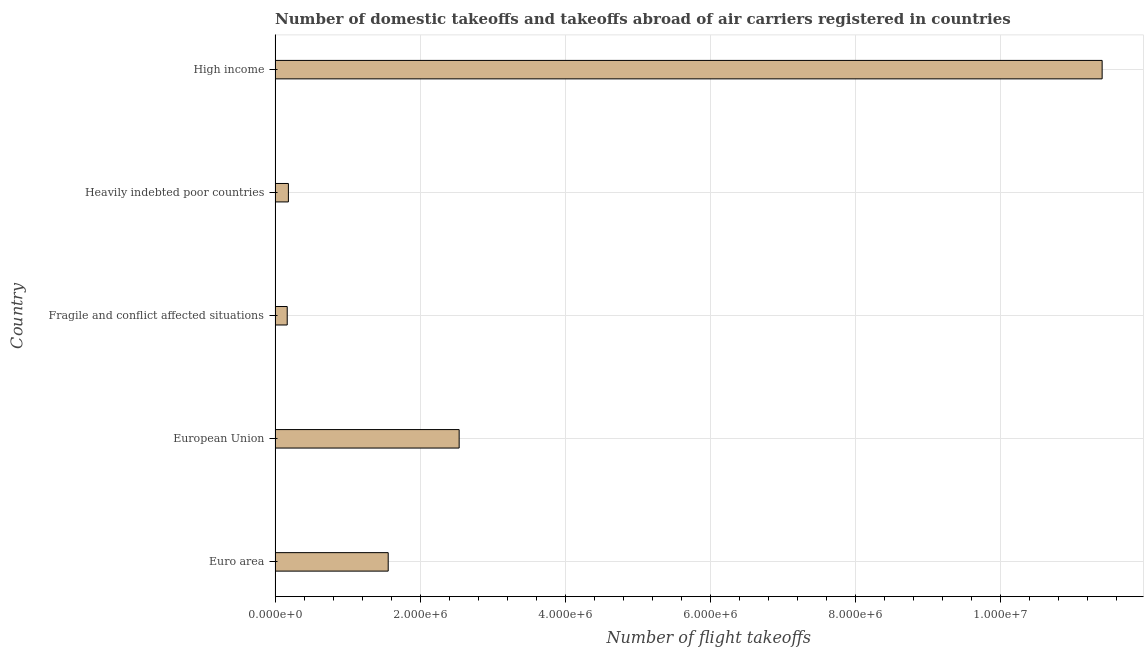Does the graph contain any zero values?
Offer a terse response. No. Does the graph contain grids?
Give a very brief answer. Yes. What is the title of the graph?
Give a very brief answer. Number of domestic takeoffs and takeoffs abroad of air carriers registered in countries. What is the label or title of the X-axis?
Keep it short and to the point. Number of flight takeoffs. What is the number of flight takeoffs in Fragile and conflict affected situations?
Provide a short and direct response. 1.67e+05. Across all countries, what is the maximum number of flight takeoffs?
Your response must be concise. 1.14e+07. Across all countries, what is the minimum number of flight takeoffs?
Offer a terse response. 1.67e+05. In which country was the number of flight takeoffs maximum?
Make the answer very short. High income. In which country was the number of flight takeoffs minimum?
Give a very brief answer. Fragile and conflict affected situations. What is the sum of the number of flight takeoffs?
Provide a short and direct response. 1.58e+07. What is the difference between the number of flight takeoffs in European Union and High income?
Your answer should be very brief. -8.86e+06. What is the average number of flight takeoffs per country?
Offer a very short reply. 3.17e+06. What is the median number of flight takeoffs?
Keep it short and to the point. 1.56e+06. In how many countries, is the number of flight takeoffs greater than 2800000 ?
Give a very brief answer. 1. What is the ratio of the number of flight takeoffs in Heavily indebted poor countries to that in High income?
Your response must be concise. 0.02. What is the difference between the highest and the second highest number of flight takeoffs?
Your answer should be very brief. 8.86e+06. Is the sum of the number of flight takeoffs in Euro area and Fragile and conflict affected situations greater than the maximum number of flight takeoffs across all countries?
Keep it short and to the point. No. What is the difference between the highest and the lowest number of flight takeoffs?
Keep it short and to the point. 1.12e+07. How many bars are there?
Offer a very short reply. 5. Are all the bars in the graph horizontal?
Give a very brief answer. Yes. How many countries are there in the graph?
Provide a succinct answer. 5. What is the difference between two consecutive major ticks on the X-axis?
Your answer should be compact. 2.00e+06. What is the Number of flight takeoffs of Euro area?
Provide a short and direct response. 1.56e+06. What is the Number of flight takeoffs in European Union?
Provide a succinct answer. 2.54e+06. What is the Number of flight takeoffs of Fragile and conflict affected situations?
Offer a very short reply. 1.67e+05. What is the Number of flight takeoffs of Heavily indebted poor countries?
Make the answer very short. 1.83e+05. What is the Number of flight takeoffs of High income?
Your response must be concise. 1.14e+07. What is the difference between the Number of flight takeoffs in Euro area and European Union?
Offer a very short reply. -9.78e+05. What is the difference between the Number of flight takeoffs in Euro area and Fragile and conflict affected situations?
Your answer should be very brief. 1.39e+06. What is the difference between the Number of flight takeoffs in Euro area and Heavily indebted poor countries?
Offer a very short reply. 1.38e+06. What is the difference between the Number of flight takeoffs in Euro area and High income?
Your response must be concise. -9.84e+06. What is the difference between the Number of flight takeoffs in European Union and Fragile and conflict affected situations?
Offer a terse response. 2.37e+06. What is the difference between the Number of flight takeoffs in European Union and Heavily indebted poor countries?
Your answer should be very brief. 2.35e+06. What is the difference between the Number of flight takeoffs in European Union and High income?
Your response must be concise. -8.86e+06. What is the difference between the Number of flight takeoffs in Fragile and conflict affected situations and Heavily indebted poor countries?
Provide a short and direct response. -1.60e+04. What is the difference between the Number of flight takeoffs in Fragile and conflict affected situations and High income?
Ensure brevity in your answer.  -1.12e+07. What is the difference between the Number of flight takeoffs in Heavily indebted poor countries and High income?
Provide a succinct answer. -1.12e+07. What is the ratio of the Number of flight takeoffs in Euro area to that in European Union?
Your answer should be very brief. 0.61. What is the ratio of the Number of flight takeoffs in Euro area to that in Fragile and conflict affected situations?
Keep it short and to the point. 9.32. What is the ratio of the Number of flight takeoffs in Euro area to that in Heavily indebted poor countries?
Offer a terse response. 8.5. What is the ratio of the Number of flight takeoffs in Euro area to that in High income?
Your response must be concise. 0.14. What is the ratio of the Number of flight takeoffs in European Union to that in Fragile and conflict affected situations?
Provide a succinct answer. 15.16. What is the ratio of the Number of flight takeoffs in European Union to that in Heavily indebted poor countries?
Your answer should be very brief. 13.84. What is the ratio of the Number of flight takeoffs in European Union to that in High income?
Your answer should be very brief. 0.22. What is the ratio of the Number of flight takeoffs in Fragile and conflict affected situations to that in High income?
Your answer should be compact. 0.01. What is the ratio of the Number of flight takeoffs in Heavily indebted poor countries to that in High income?
Offer a very short reply. 0.02. 